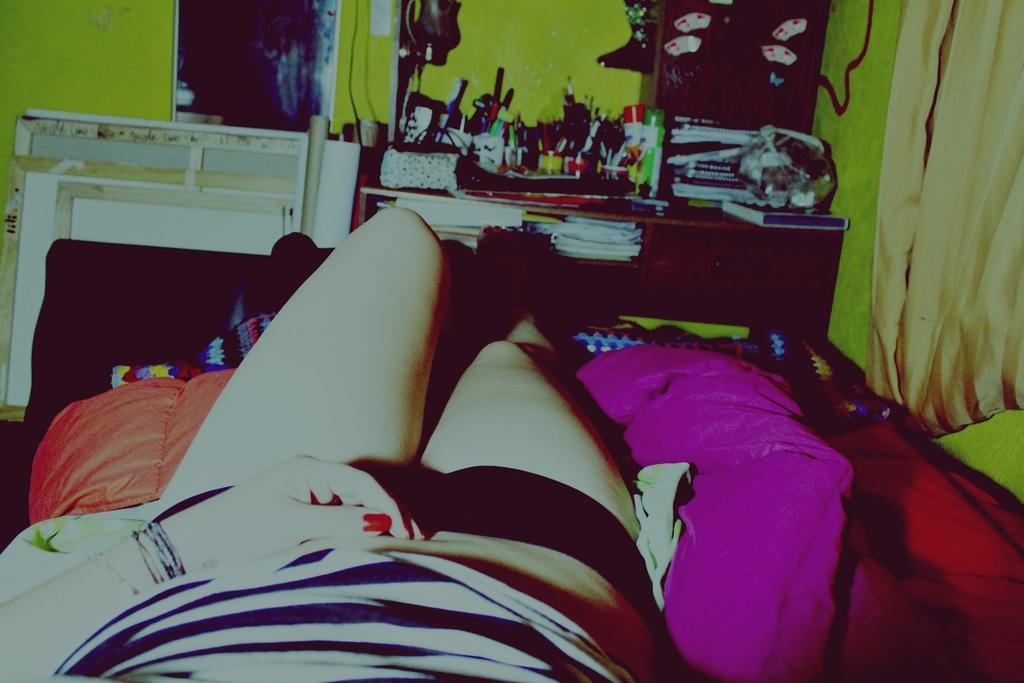How would you summarize this image in a sentence or two? In the picture we can see a person sleeping on the bed, in the background we can see a table, on the table we can find many things like pens, papers, bottles, books etc. 